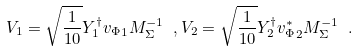<formula> <loc_0><loc_0><loc_500><loc_500>V _ { 1 } = \sqrt { \frac { 1 } { 1 0 } } Y ^ { \dagger } _ { 1 } { v _ { \Phi } } _ { 1 } M ^ { - 1 } _ { \Sigma } \ , V _ { 2 } = \sqrt { \frac { 1 } { 1 0 } } Y ^ { \dagger } _ { 2 } { v ^ { * } _ { \Phi } } _ { 2 } M ^ { - 1 } _ { \Sigma } \ .</formula> 